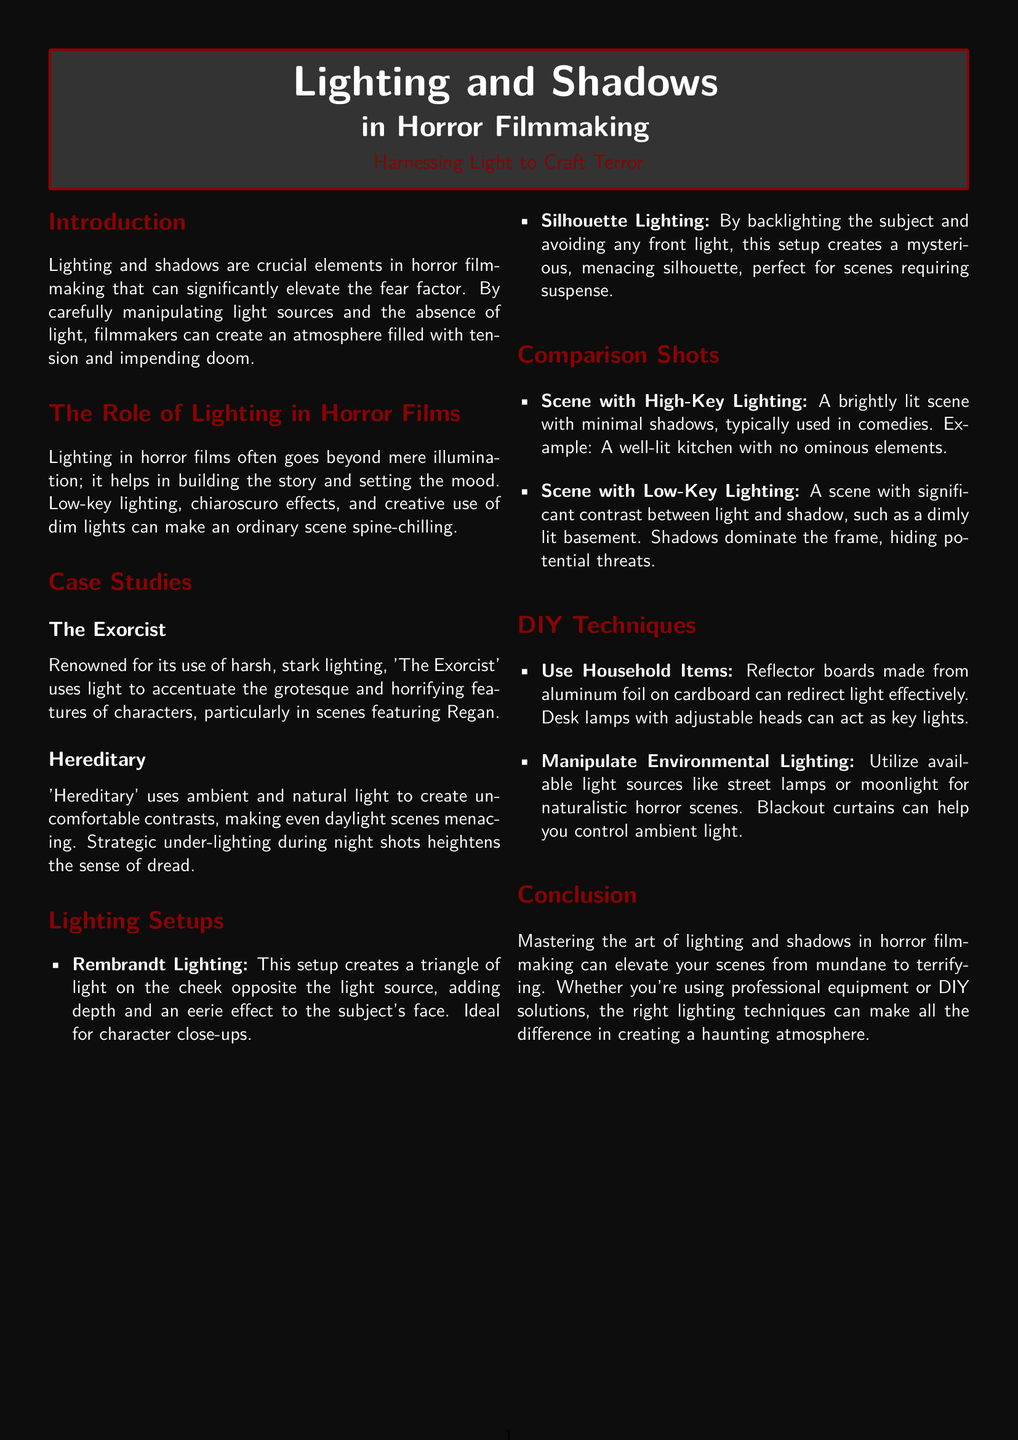What is the focus of the magazine article? The article focuses on how lighting can enhance the terrifying atmosphere in horror scenes.
Answer: lighting and shadows in horror filmmaking What is one prominent horror film mentioned in the case studies? The article cites specific films as examples of effective lighting use.
Answer: The Exorcist What lighting effect does Rembrandt Lighting create? Rembrandt lighting is specified to create a triangle of light on the cheek opposite the light source.
Answer: triangle of light Which setup is described as creating a mysterious silhouette? The section on lighting setups indicates specific setups for visual effects in horror.
Answer: Silhouette Lighting What household item is suggested for use as a reflector board? The DIY techniques suggest materials commonly found in homes that can aid in lighting setups.
Answer: aluminum foil What is one key characteristic of low-key lighting? Low-key lighting is described in the comparison shots section to illustrate its contrasting nature.
Answer: significant contrast How does 'Hereditary' use lighting to affect scenes? The case study of 'Hereditary' outlines the specific use of light during certain scenes for emotional impact.
Answer: ambient and natural light What is the primary outcome of effective lighting in horror filmmaking? The conclusion summarizes the main purpose of mastering lighting techniques in horror contexts.
Answer: elevate scenes from mundane to terrifying 